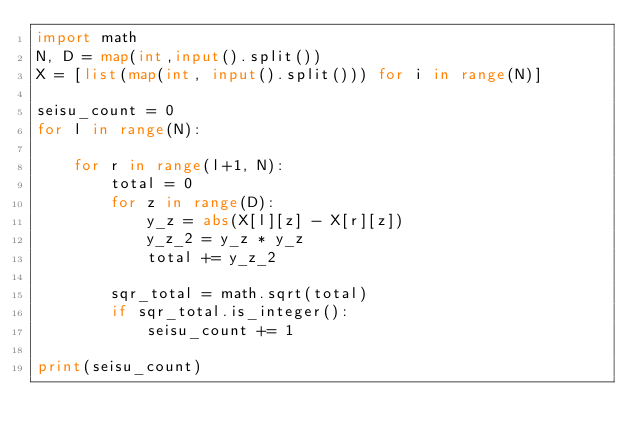Convert code to text. <code><loc_0><loc_0><loc_500><loc_500><_Python_>import math
N, D = map(int,input().split())
X = [list(map(int, input().split())) for i in range(N)]

seisu_count = 0
for l in range(N):

    for r in range(l+1, N):
        total = 0
        for z in range(D):
            y_z = abs(X[l][z] - X[r][z])
            y_z_2 = y_z * y_z
            total += y_z_2
        
        sqr_total = math.sqrt(total)
        if sqr_total.is_integer():
            seisu_count += 1

print(seisu_count)</code> 